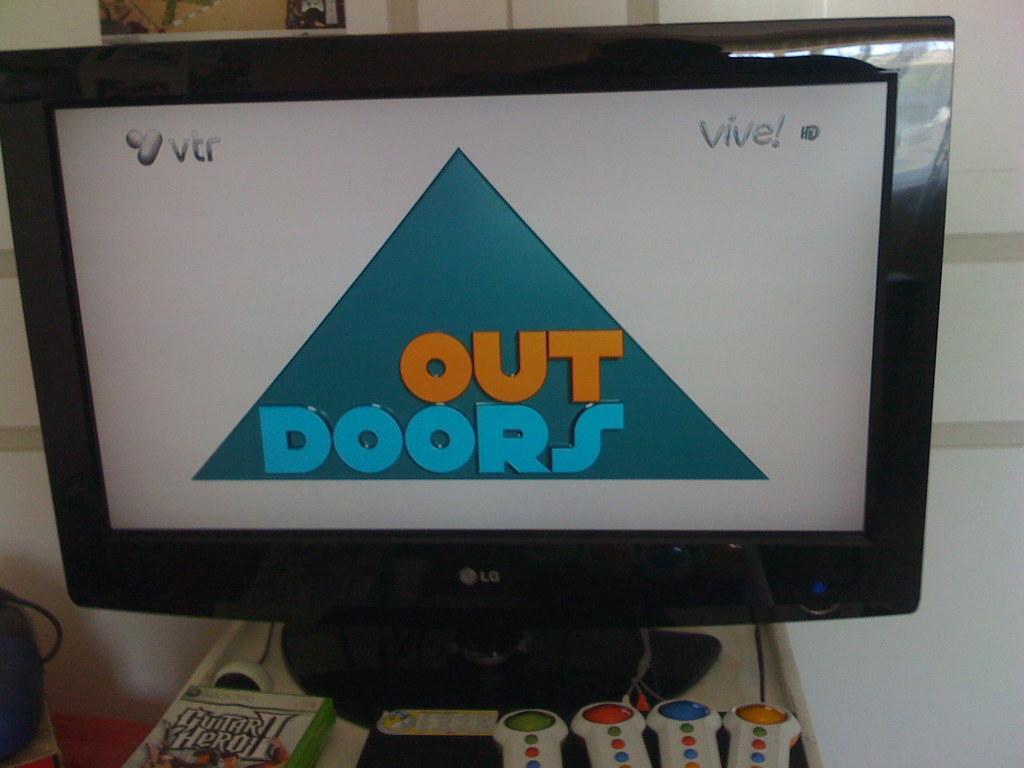In one or two sentences, can you explain what this image depicts? In this picture in the front there are objects which are white in colour, there is a book with some text written on it. In the center there is a monitor with some text displaying on it and in the background there is wall, on the left side there is an object which is black in colour. 